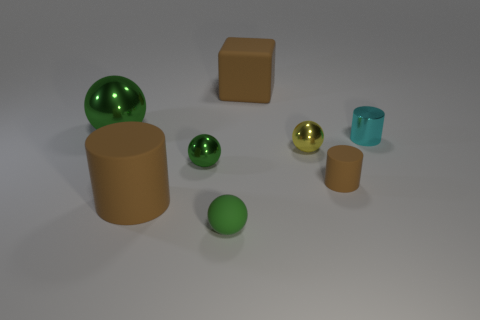Is the number of big brown matte cylinders to the right of the large metallic sphere less than the number of small green matte balls?
Ensure brevity in your answer.  No. There is a tiny green matte ball; how many yellow metal things are in front of it?
Provide a short and direct response. 0. What is the size of the green ball behind the small metallic ball left of the brown matte object behind the cyan cylinder?
Offer a very short reply. Large. There is a small yellow shiny object; is it the same shape as the tiny green object that is on the left side of the tiny green matte ball?
Offer a very short reply. Yes. What size is the cyan cylinder that is made of the same material as the tiny yellow thing?
Your response must be concise. Small. Is there any other thing that has the same color as the small metal cylinder?
Offer a terse response. No. What is the material of the big brown thing behind the yellow shiny ball that is left of the brown rubber object right of the tiny yellow ball?
Give a very brief answer. Rubber. How many matte things are small brown objects or large brown cylinders?
Offer a very short reply. 2. Do the small rubber sphere and the large metal ball have the same color?
Make the answer very short. Yes. What number of things are either tiny brown spheres or small things in front of the yellow metallic object?
Provide a short and direct response. 3. 